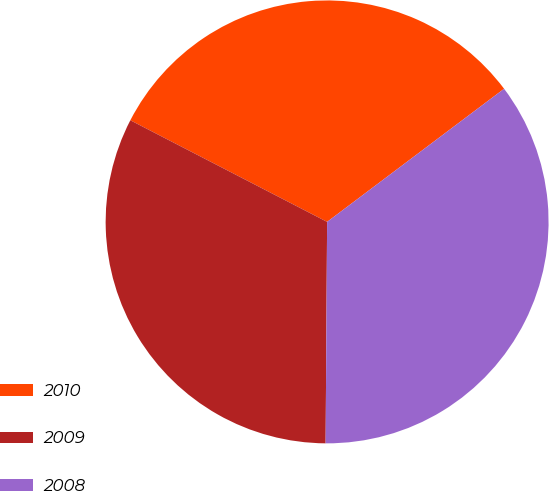Convert chart to OTSL. <chart><loc_0><loc_0><loc_500><loc_500><pie_chart><fcel>2010<fcel>2009<fcel>2008<nl><fcel>32.15%<fcel>32.48%<fcel>35.37%<nl></chart> 